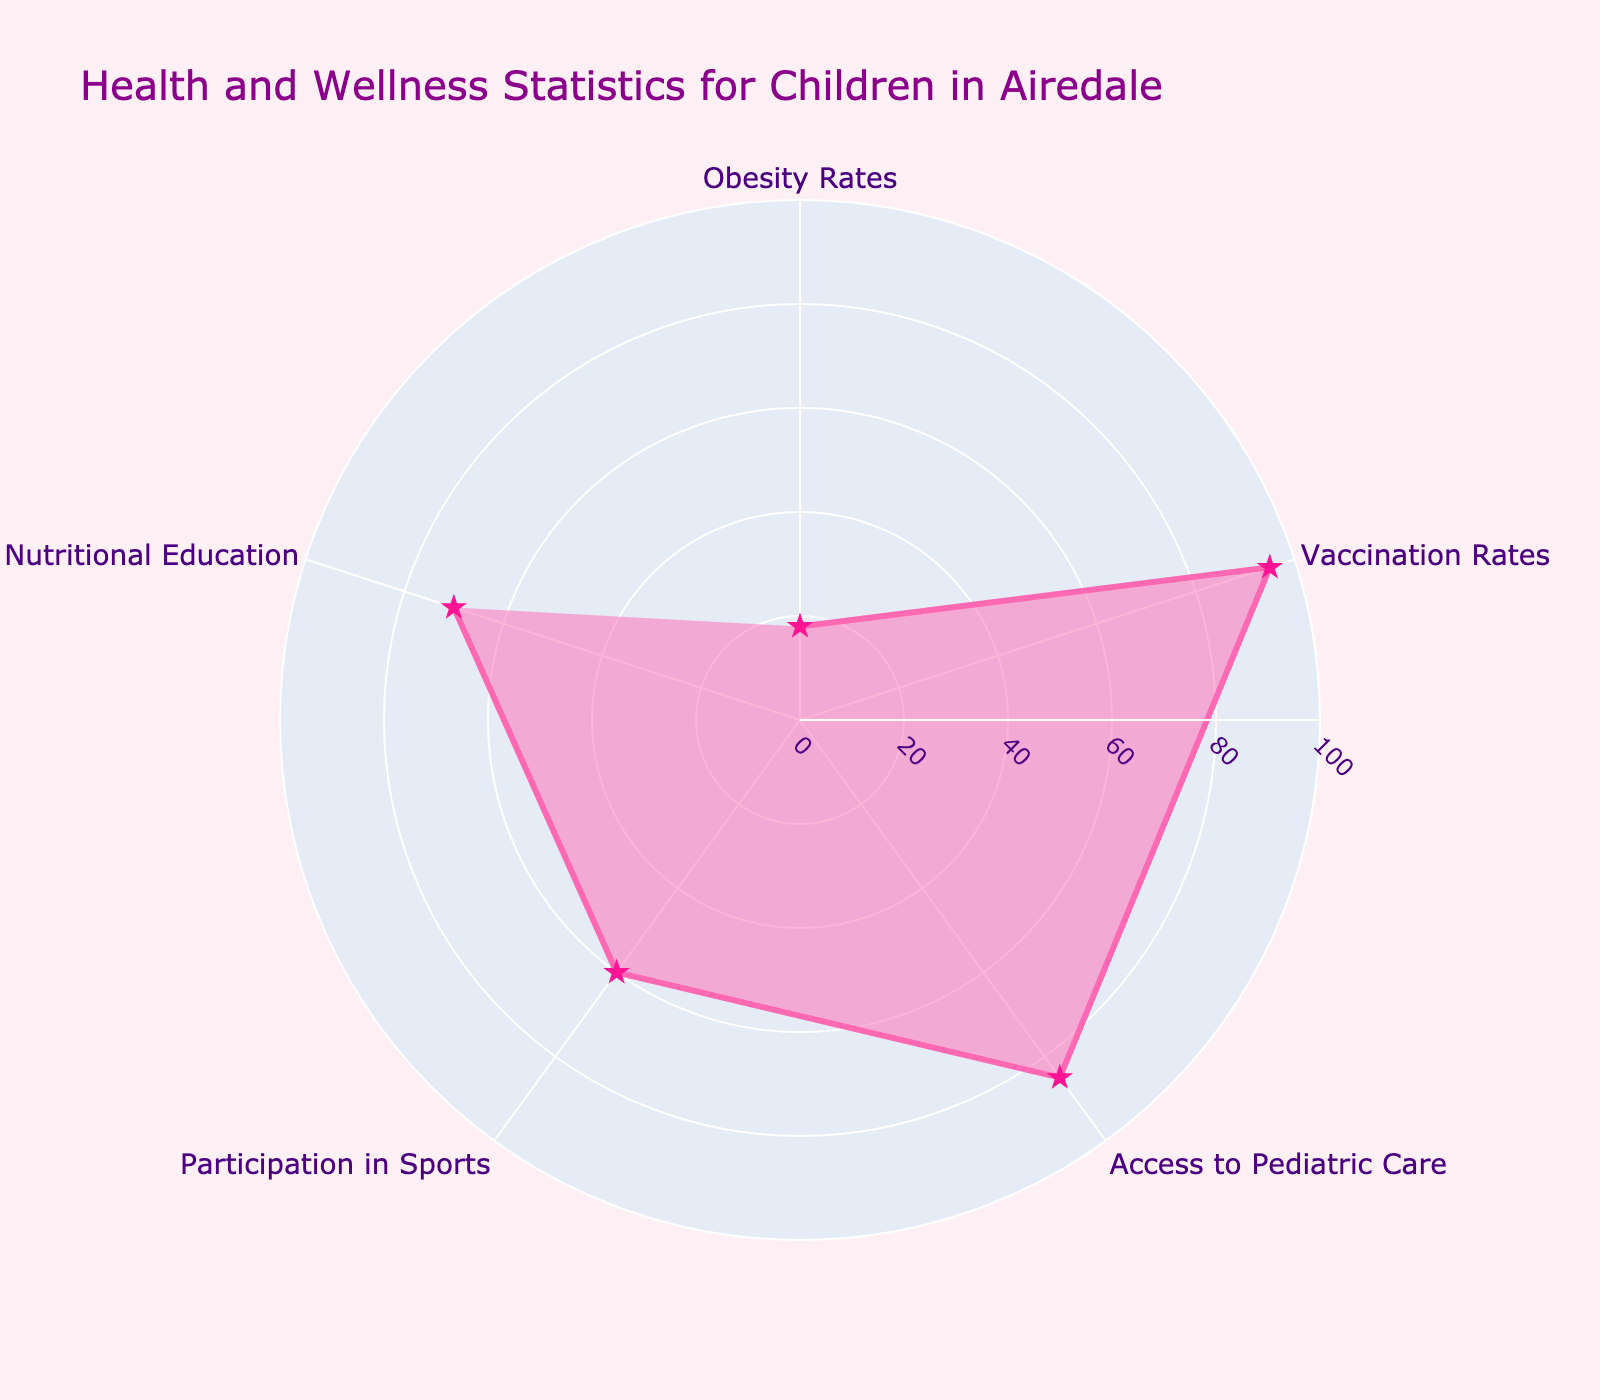What's the title of the radar chart? The title of the chart is a basic element located at the top of the plot. It’s designed to give an overview of what the chart represents, summarizing the main topic. In this case, it reflects the key focus of the data presented.
Answer: Health and Wellness Statistics for Children in Airedale How many categories are displayed in the chart? By visually counting the distinct data points (segments) presented around the radar chart, each corresponding to a separate category, we can determine the total number of categories.
Answer: 5 Which category has the lowest rate? To determine the category with the lowest rate, visually scan each data point around the chart and identify the point with the shortest radius. This represents the smallest percentage value.
Answer: Obesity Rates What is the difference in rates between Participation in Sports and Nutritional Education? Locate the data points for Participation in Sports (60%) and Nutritional Education (70%) and calculate their difference by subtracting the smaller percentage from the larger one.
Answer: 10% What is the average rate of all categories displayed in the chart? To find the average rate, first sum the rates: 18% (Obesity Rates) + 95% (Vaccination Rates) + 85% (Access to Pediatric Care) + 60% (Participation in Sports) + 70% (Nutritional Education) = 328%. Then, divide the total by the number of categories (5).
Answer: 65.6% Which rate is higher: Access to Pediatric Care or Vaccination Rates? Compare the values of the Access to Pediatric Care rate (85%) and the Vaccination Rates (95%) by visually examining the chart or recalling the specific values.
Answer: Vaccination Rates Identify the categories that have rates greater than 80%. Review each data point and check if the corresponding rate exceeds 80%. The categories that qualify are identified based on this threshold.
Answer: Vaccination Rates, Access to Pediatric Care What's the sum of the rates for categories with less than 70%? Identify and sum the rates of categories that are below 70%: Obesity Rates (18%), Participation in Sports (60%). Adding these values results in the total.
Answer: 78% Which category shows a potential concern due to its high rate? A high rate in certain contexts, like health concerns, often signifies a problem. Obesity Rates stands out due to its impact on child health. Therefore, identify the rate that is high and poses a health risk.
Answer: Obesity Rates What percentage point increase is needed for Participation in Sports to reach the rate of Nutritional Education? Subtract the current rate of Participation in Sports (60%) from the rate of Nutritional Education (70%) to determine the required increase.
Answer: 10% 